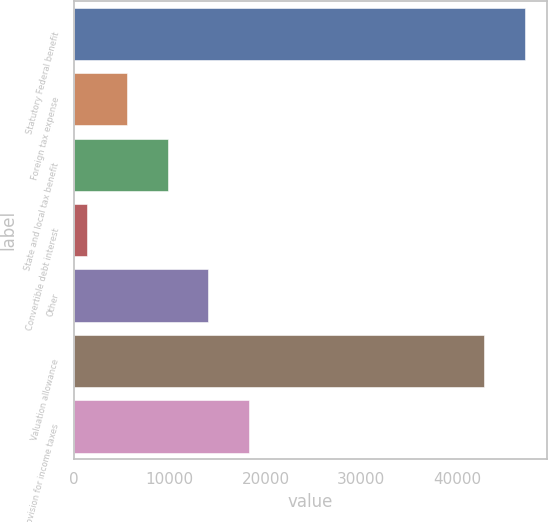Convert chart. <chart><loc_0><loc_0><loc_500><loc_500><bar_chart><fcel>Statutory Federal benefit<fcel>Foreign tax expense<fcel>State and local tax benefit<fcel>Convertible debt interest<fcel>Other<fcel>Valuation allowance<fcel>Provision for income taxes<nl><fcel>47066<fcel>5567<fcel>9801<fcel>1333<fcel>14035<fcel>42832<fcel>18269<nl></chart> 